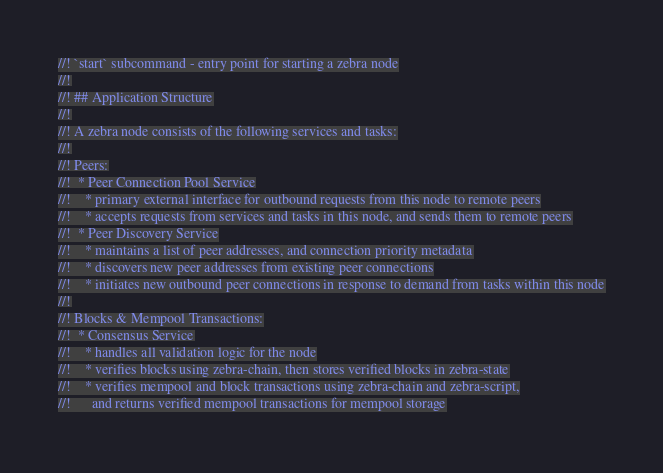<code> <loc_0><loc_0><loc_500><loc_500><_Rust_>//! `start` subcommand - entry point for starting a zebra node
//!
//! ## Application Structure
//!
//! A zebra node consists of the following services and tasks:
//!
//! Peers:
//!  * Peer Connection Pool Service
//!    * primary external interface for outbound requests from this node to remote peers
//!    * accepts requests from services and tasks in this node, and sends them to remote peers
//!  * Peer Discovery Service
//!    * maintains a list of peer addresses, and connection priority metadata
//!    * discovers new peer addresses from existing peer connections
//!    * initiates new outbound peer connections in response to demand from tasks within this node
//!
//! Blocks & Mempool Transactions:
//!  * Consensus Service
//!    * handles all validation logic for the node
//!    * verifies blocks using zebra-chain, then stores verified blocks in zebra-state
//!    * verifies mempool and block transactions using zebra-chain and zebra-script,
//!      and returns verified mempool transactions for mempool storage</code> 